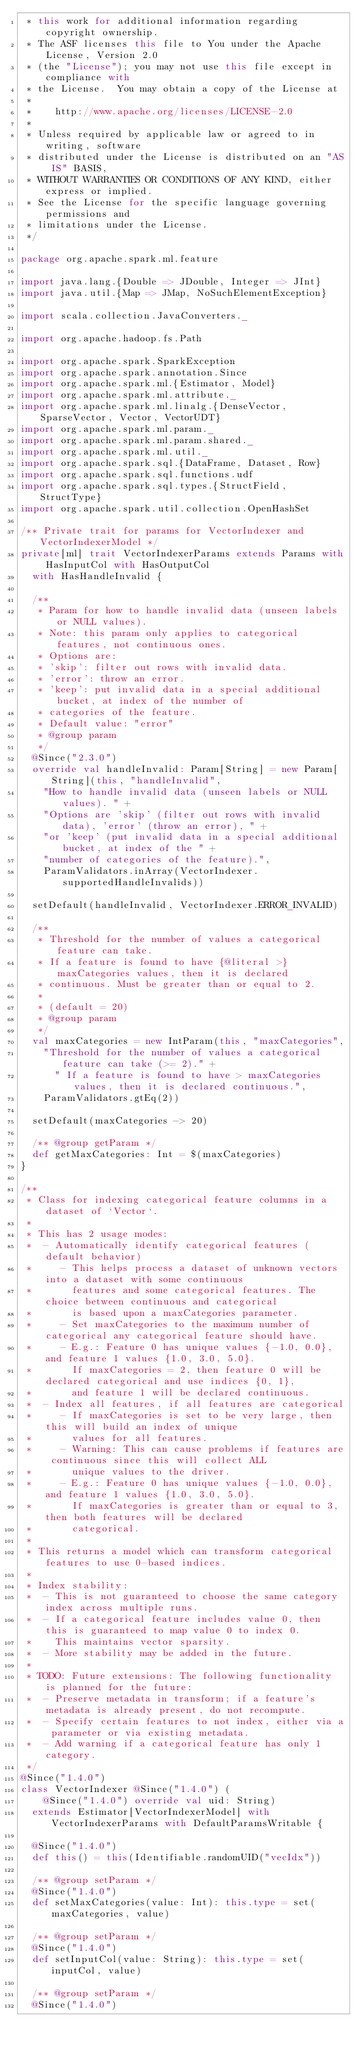Convert code to text. <code><loc_0><loc_0><loc_500><loc_500><_Scala_> * this work for additional information regarding copyright ownership.
 * The ASF licenses this file to You under the Apache License, Version 2.0
 * (the "License"); you may not use this file except in compliance with
 * the License.  You may obtain a copy of the License at
 *
 *    http://www.apache.org/licenses/LICENSE-2.0
 *
 * Unless required by applicable law or agreed to in writing, software
 * distributed under the License is distributed on an "AS IS" BASIS,
 * WITHOUT WARRANTIES OR CONDITIONS OF ANY KIND, either express or implied.
 * See the License for the specific language governing permissions and
 * limitations under the License.
 */

package org.apache.spark.ml.feature

import java.lang.{Double => JDouble, Integer => JInt}
import java.util.{Map => JMap, NoSuchElementException}

import scala.collection.JavaConverters._

import org.apache.hadoop.fs.Path

import org.apache.spark.SparkException
import org.apache.spark.annotation.Since
import org.apache.spark.ml.{Estimator, Model}
import org.apache.spark.ml.attribute._
import org.apache.spark.ml.linalg.{DenseVector, SparseVector, Vector, VectorUDT}
import org.apache.spark.ml.param._
import org.apache.spark.ml.param.shared._
import org.apache.spark.ml.util._
import org.apache.spark.sql.{DataFrame, Dataset, Row}
import org.apache.spark.sql.functions.udf
import org.apache.spark.sql.types.{StructField, StructType}
import org.apache.spark.util.collection.OpenHashSet

/** Private trait for params for VectorIndexer and VectorIndexerModel */
private[ml] trait VectorIndexerParams extends Params with HasInputCol with HasOutputCol
  with HasHandleInvalid {

  /**
   * Param for how to handle invalid data (unseen labels or NULL values).
   * Note: this param only applies to categorical features, not continuous ones.
   * Options are:
   * 'skip': filter out rows with invalid data.
   * 'error': throw an error.
   * 'keep': put invalid data in a special additional bucket, at index of the number of
   * categories of the feature.
   * Default value: "error"
   * @group param
   */
  @Since("2.3.0")
  override val handleInvalid: Param[String] = new Param[String](this, "handleInvalid",
    "How to handle invalid data (unseen labels or NULL values). " +
    "Options are 'skip' (filter out rows with invalid data), 'error' (throw an error), " +
    "or 'keep' (put invalid data in a special additional bucket, at index of the " +
    "number of categories of the feature).",
    ParamValidators.inArray(VectorIndexer.supportedHandleInvalids))

  setDefault(handleInvalid, VectorIndexer.ERROR_INVALID)

  /**
   * Threshold for the number of values a categorical feature can take.
   * If a feature is found to have {@literal >} maxCategories values, then it is declared
   * continuous. Must be greater than or equal to 2.
   *
   * (default = 20)
   * @group param
   */
  val maxCategories = new IntParam(this, "maxCategories",
    "Threshold for the number of values a categorical feature can take (>= 2)." +
      " If a feature is found to have > maxCategories values, then it is declared continuous.",
    ParamValidators.gtEq(2))

  setDefault(maxCategories -> 20)

  /** @group getParam */
  def getMaxCategories: Int = $(maxCategories)
}

/**
 * Class for indexing categorical feature columns in a dataset of `Vector`.
 *
 * This has 2 usage modes:
 *  - Automatically identify categorical features (default behavior)
 *     - This helps process a dataset of unknown vectors into a dataset with some continuous
 *       features and some categorical features. The choice between continuous and categorical
 *       is based upon a maxCategories parameter.
 *     - Set maxCategories to the maximum number of categorical any categorical feature should have.
 *     - E.g.: Feature 0 has unique values {-1.0, 0.0}, and feature 1 values {1.0, 3.0, 5.0}.
 *       If maxCategories = 2, then feature 0 will be declared categorical and use indices {0, 1},
 *       and feature 1 will be declared continuous.
 *  - Index all features, if all features are categorical
 *     - If maxCategories is set to be very large, then this will build an index of unique
 *       values for all features.
 *     - Warning: This can cause problems if features are continuous since this will collect ALL
 *       unique values to the driver.
 *     - E.g.: Feature 0 has unique values {-1.0, 0.0}, and feature 1 values {1.0, 3.0, 5.0}.
 *       If maxCategories is greater than or equal to 3, then both features will be declared
 *       categorical.
 *
 * This returns a model which can transform categorical features to use 0-based indices.
 *
 * Index stability:
 *  - This is not guaranteed to choose the same category index across multiple runs.
 *  - If a categorical feature includes value 0, then this is guaranteed to map value 0 to index 0.
 *    This maintains vector sparsity.
 *  - More stability may be added in the future.
 *
 * TODO: Future extensions: The following functionality is planned for the future:
 *  - Preserve metadata in transform; if a feature's metadata is already present, do not recompute.
 *  - Specify certain features to not index, either via a parameter or via existing metadata.
 *  - Add warning if a categorical feature has only 1 category.
 */
@Since("1.4.0")
class VectorIndexer @Since("1.4.0") (
    @Since("1.4.0") override val uid: String)
  extends Estimator[VectorIndexerModel] with VectorIndexerParams with DefaultParamsWritable {

  @Since("1.4.0")
  def this() = this(Identifiable.randomUID("vecIdx"))

  /** @group setParam */
  @Since("1.4.0")
  def setMaxCategories(value: Int): this.type = set(maxCategories, value)

  /** @group setParam */
  @Since("1.4.0")
  def setInputCol(value: String): this.type = set(inputCol, value)

  /** @group setParam */
  @Since("1.4.0")</code> 